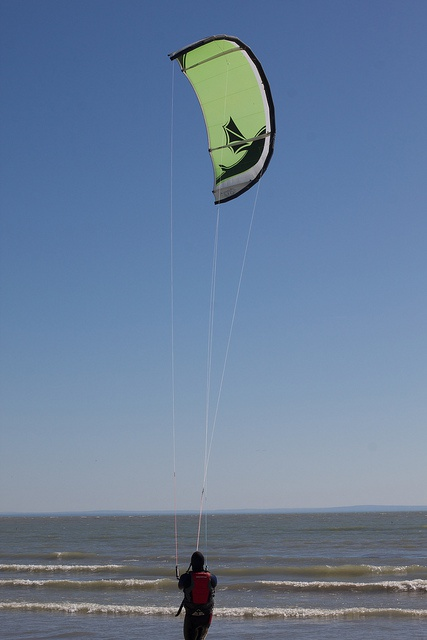Describe the objects in this image and their specific colors. I can see kite in blue, lightgreen, black, gray, and darkgray tones, people in blue, black, gray, maroon, and navy tones, and backpack in blue, black, maroon, and brown tones in this image. 